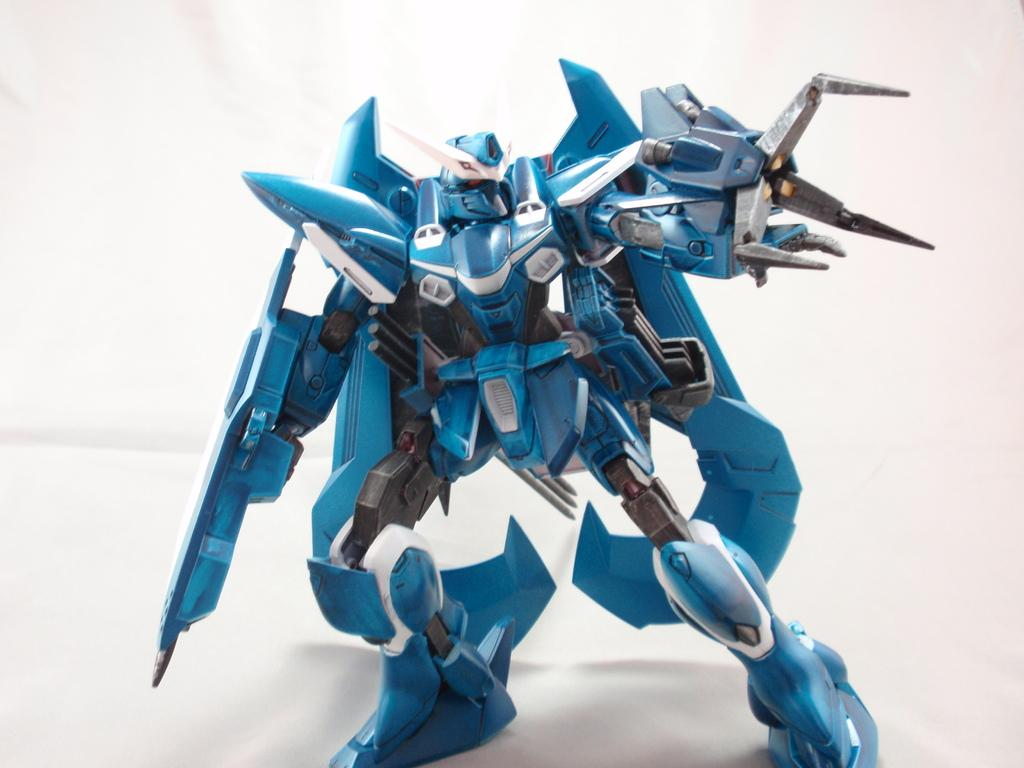What is the main subject of the image? The main subject of the image is a toy robot. Where is the toy robot located in the image? The toy robot is standing in the center of the image. What color is the background of the image? The background of the image is white in color. How many cakes are on the base that the toy robot is standing on? There are no cakes or bases present in the image; it only features a toy robot standing in the center of a white background. 